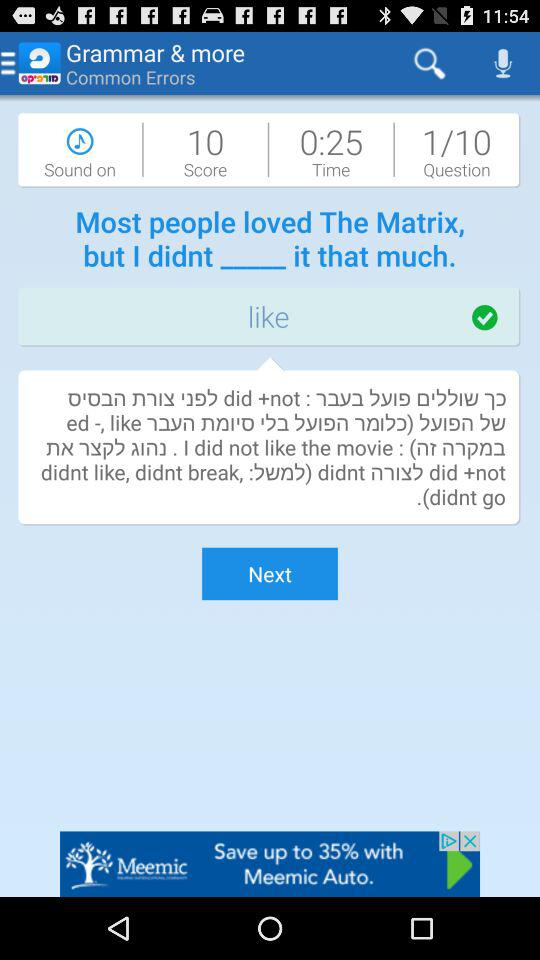What is the score? The score is 10. 